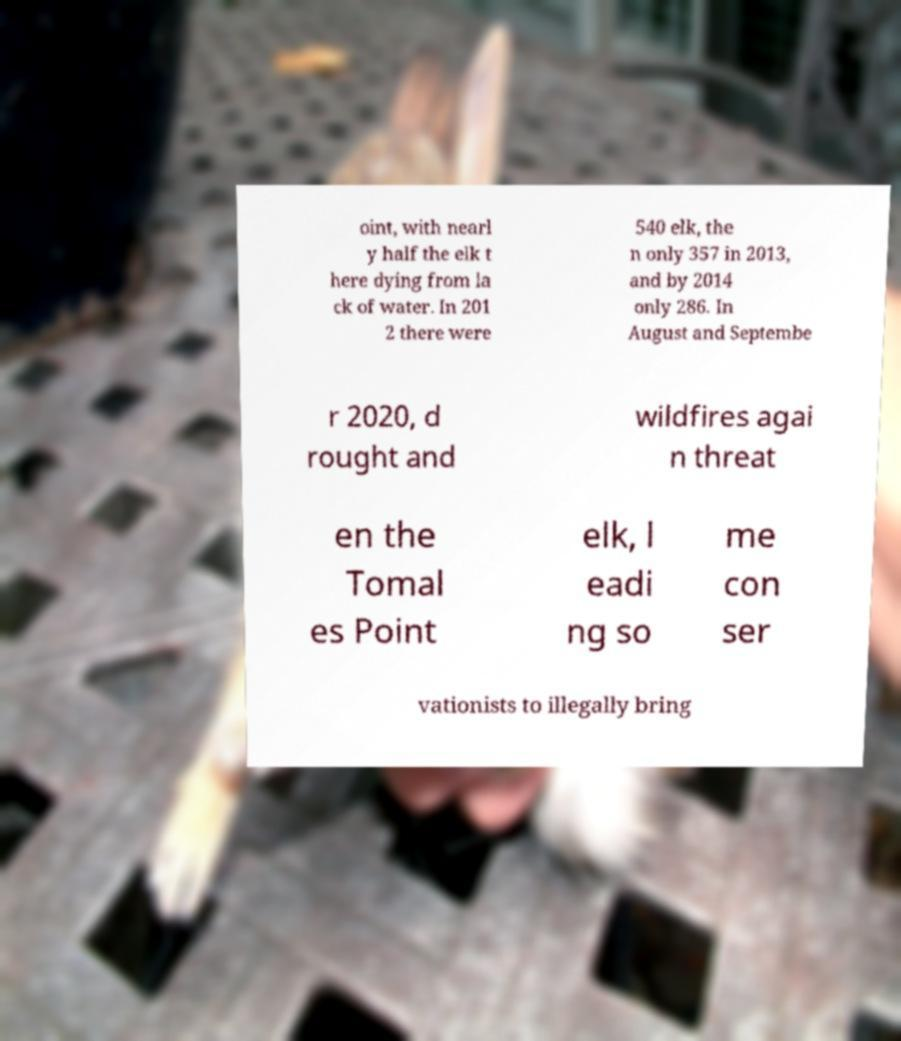There's text embedded in this image that I need extracted. Can you transcribe it verbatim? oint, with nearl y half the elk t here dying from la ck of water. In 201 2 there were 540 elk, the n only 357 in 2013, and by 2014 only 286. In August and Septembe r 2020, d rought and wildfires agai n threat en the Tomal es Point elk, l eadi ng so me con ser vationists to illegally bring 